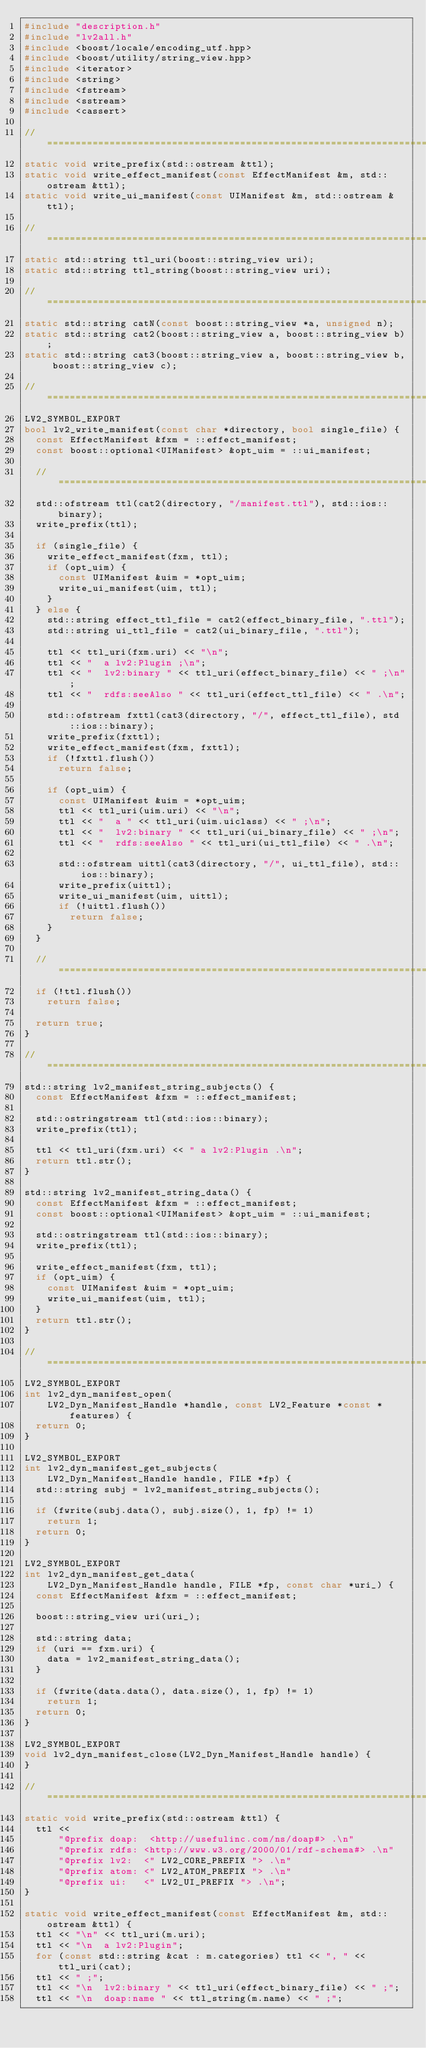<code> <loc_0><loc_0><loc_500><loc_500><_C++_>#include "description.h"
#include "lv2all.h"
#include <boost/locale/encoding_utf.hpp>
#include <boost/utility/string_view.hpp>
#include <iterator>
#include <string>
#include <fstream>
#include <sstream>
#include <cassert>

//==============================================================================
static void write_prefix(std::ostream &ttl);
static void write_effect_manifest(const EffectManifest &m, std::ostream &ttl);
static void write_ui_manifest(const UIManifest &m, std::ostream &ttl);

//==============================================================================
static std::string ttl_uri(boost::string_view uri);
static std::string ttl_string(boost::string_view uri);

//==============================================================================
static std::string catN(const boost::string_view *a, unsigned n);
static std::string cat2(boost::string_view a, boost::string_view b);
static std::string cat3(boost::string_view a, boost::string_view b, boost::string_view c);

//==============================================================================
LV2_SYMBOL_EXPORT
bool lv2_write_manifest(const char *directory, bool single_file) {
  const EffectManifest &fxm = ::effect_manifest;
  const boost::optional<UIManifest> &opt_uim = ::ui_manifest;

  //============================================================================
  std::ofstream ttl(cat2(directory, "/manifest.ttl"), std::ios::binary);
  write_prefix(ttl);

  if (single_file) {
    write_effect_manifest(fxm, ttl);
    if (opt_uim) {
      const UIManifest &uim = *opt_uim;
      write_ui_manifest(uim, ttl);
    }
  } else {
    std::string effect_ttl_file = cat2(effect_binary_file, ".ttl");
    std::string ui_ttl_file = cat2(ui_binary_file, ".ttl");

    ttl << ttl_uri(fxm.uri) << "\n";
    ttl << "  a lv2:Plugin ;\n";
    ttl << "  lv2:binary " << ttl_uri(effect_binary_file) << " ;\n";
    ttl << "  rdfs:seeAlso " << ttl_uri(effect_ttl_file) << " .\n";

    std::ofstream fxttl(cat3(directory, "/", effect_ttl_file), std::ios::binary);
    write_prefix(fxttl);
    write_effect_manifest(fxm, fxttl);
    if (!fxttl.flush())
      return false;

    if (opt_uim) {
      const UIManifest &uim = *opt_uim;
      ttl << ttl_uri(uim.uri) << "\n";
      ttl << "  a " << ttl_uri(uim.uiclass) << " ;\n";
      ttl << "  lv2:binary " << ttl_uri(ui_binary_file) << " ;\n";
      ttl << "  rdfs:seeAlso " << ttl_uri(ui_ttl_file) << " .\n";

      std::ofstream uittl(cat3(directory, "/", ui_ttl_file), std::ios::binary);
      write_prefix(uittl);
      write_ui_manifest(uim, uittl);
      if (!uittl.flush())
        return false;
    }
  }

  //============================================================================
  if (!ttl.flush())
    return false;

  return true;
}

//============================================================================
std::string lv2_manifest_string_subjects() {
  const EffectManifest &fxm = ::effect_manifest;

  std::ostringstream ttl(std::ios::binary);
  write_prefix(ttl);

  ttl << ttl_uri(fxm.uri) << " a lv2:Plugin .\n";
  return ttl.str();
}

std::string lv2_manifest_string_data() {
  const EffectManifest &fxm = ::effect_manifest;
  const boost::optional<UIManifest> &opt_uim = ::ui_manifest;

  std::ostringstream ttl(std::ios::binary);
  write_prefix(ttl);

  write_effect_manifest(fxm, ttl);
  if (opt_uim) {
    const UIManifest &uim = *opt_uim;
    write_ui_manifest(uim, ttl);
  }
  return ttl.str();
}

//==============================================================================
LV2_SYMBOL_EXPORT
int lv2_dyn_manifest_open(
    LV2_Dyn_Manifest_Handle *handle, const LV2_Feature *const *features) {
  return 0;
}

LV2_SYMBOL_EXPORT
int lv2_dyn_manifest_get_subjects(
    LV2_Dyn_Manifest_Handle handle, FILE *fp) {
  std::string subj = lv2_manifest_string_subjects();

  if (fwrite(subj.data(), subj.size(), 1, fp) != 1)
    return 1;
  return 0;
}

LV2_SYMBOL_EXPORT
int lv2_dyn_manifest_get_data(
    LV2_Dyn_Manifest_Handle handle, FILE *fp, const char *uri_) {
  const EffectManifest &fxm = ::effect_manifest;

  boost::string_view uri(uri_);

  std::string data;
  if (uri == fxm.uri) {
    data = lv2_manifest_string_data();
  }

  if (fwrite(data.data(), data.size(), 1, fp) != 1)
    return 1;
  return 0;
}

LV2_SYMBOL_EXPORT
void lv2_dyn_manifest_close(LV2_Dyn_Manifest_Handle handle) {
}

//==============================================================================
static void write_prefix(std::ostream &ttl) {
  ttl <<
      "@prefix doap:  <http://usefulinc.com/ns/doap#> .\n"
      "@prefix rdfs: <http://www.w3.org/2000/01/rdf-schema#> .\n"
      "@prefix lv2:  <" LV2_CORE_PREFIX "> .\n"
      "@prefix atom: <" LV2_ATOM_PREFIX "> .\n"
      "@prefix ui:   <" LV2_UI_PREFIX "> .\n";
}

static void write_effect_manifest(const EffectManifest &m, std::ostream &ttl) {
  ttl << "\n" << ttl_uri(m.uri);
  ttl << "\n  a lv2:Plugin";
  for (const std::string &cat : m.categories) ttl << ", " << ttl_uri(cat);
  ttl << " ;";
  ttl << "\n  lv2:binary " << ttl_uri(effect_binary_file) << " ;";
  ttl << "\n  doap:name " << ttl_string(m.name) << " ;";</code> 